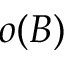<formula> <loc_0><loc_0><loc_500><loc_500>o ( B )</formula> 